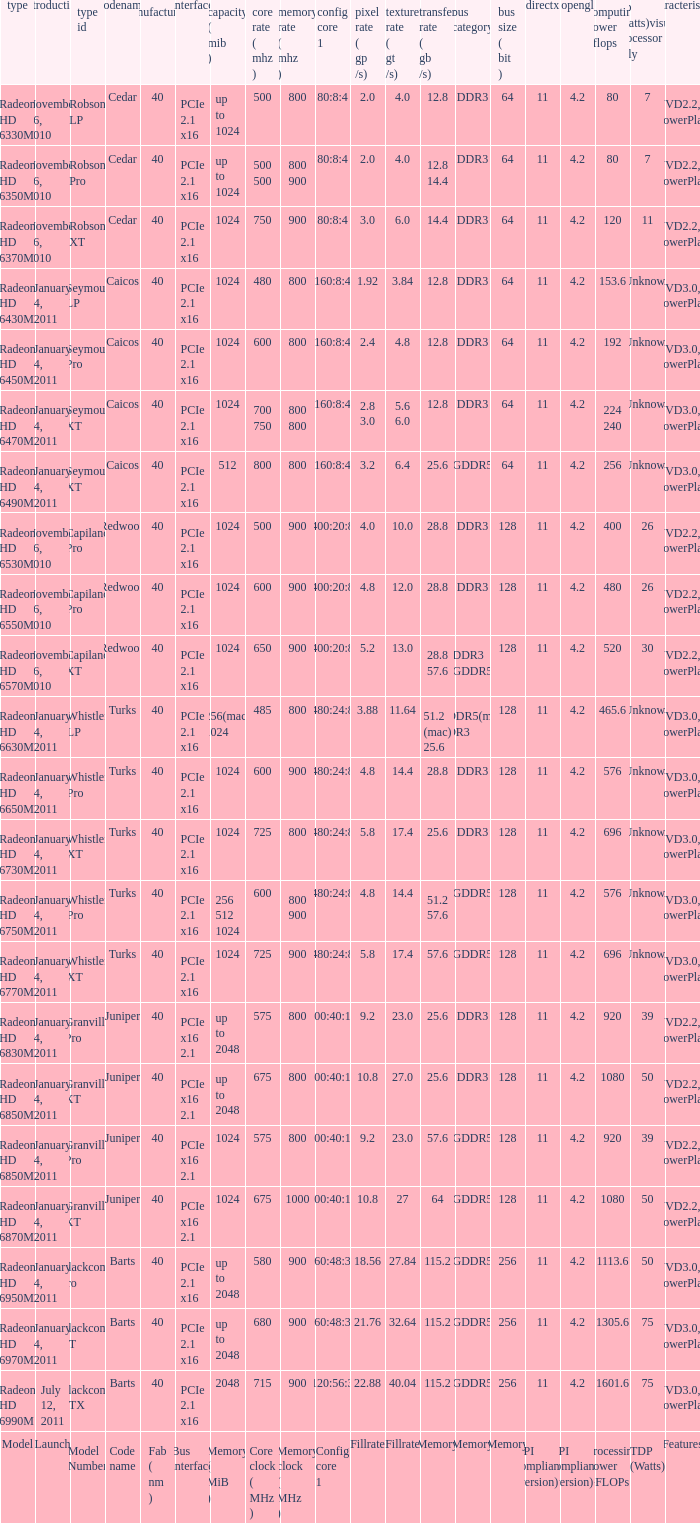What is every bus type for the texture of fillrate? Memory. 